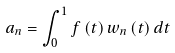Convert formula to latex. <formula><loc_0><loc_0><loc_500><loc_500>a _ { n } = \int _ { 0 } ^ { 1 } f \left ( t \right ) w _ { n } \left ( t \right ) d t</formula> 